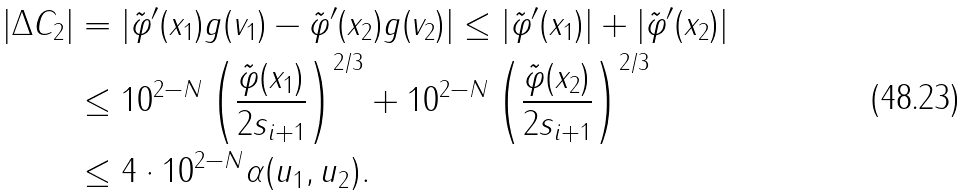<formula> <loc_0><loc_0><loc_500><loc_500>| \Delta C _ { 2 } | & = | \tilde { \varphi } ^ { \prime } ( x _ { 1 } ) g ( v _ { 1 } ) - \tilde { \varphi } ^ { \prime } ( x _ { 2 } ) g ( v _ { 2 } ) | \leq | \tilde { \varphi } ^ { \prime } ( x _ { 1 } ) | + | \tilde { \varphi } ^ { \prime } ( x _ { 2 } ) | \\ & \leq 1 0 ^ { 2 - N } \left ( \frac { \tilde { \varphi } ( x _ { 1 } ) } { 2 s _ { i + 1 } } \right ) ^ { 2 / 3 } + 1 0 ^ { 2 - N } \left ( \frac { \tilde { \varphi } ( x _ { 2 } ) } { 2 s _ { i + 1 } } \right ) ^ { 2 / 3 } \\ & \leq 4 \cdot 1 0 ^ { 2 - N } \alpha ( u _ { 1 } , u _ { 2 } ) .</formula> 